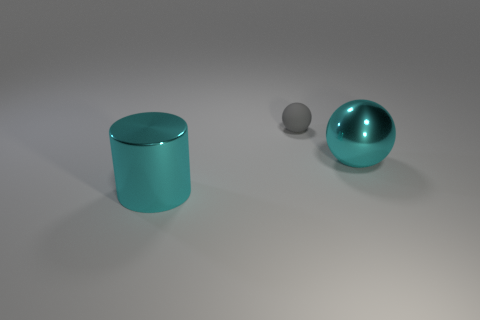Add 1 large things. How many objects exist? 4 Subtract all cylinders. How many objects are left? 2 Subtract 0 brown balls. How many objects are left? 3 Subtract all cylinders. Subtract all yellow metal things. How many objects are left? 2 Add 1 cyan cylinders. How many cyan cylinders are left? 2 Add 3 cyan metallic cylinders. How many cyan metallic cylinders exist? 4 